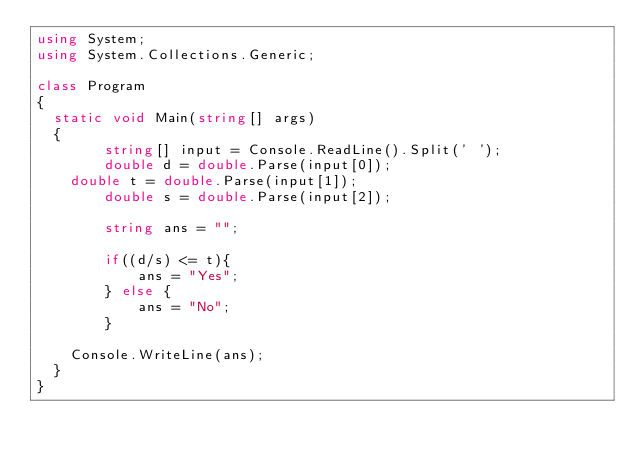Convert code to text. <code><loc_0><loc_0><loc_500><loc_500><_C#_>using System;
using System.Collections.Generic;

class Program
{
	static void Main(string[] args)
	{
        string[] input = Console.ReadLine().Split(' ');
        double d = double.Parse(input[0]);
		double t = double.Parse(input[1]);
        double s = double.Parse(input[2]);

        string ans = "";

        if((d/s) <= t){
            ans = "Yes";
        } else {
            ans = "No";
        }

		Console.WriteLine(ans);
	}
}
</code> 